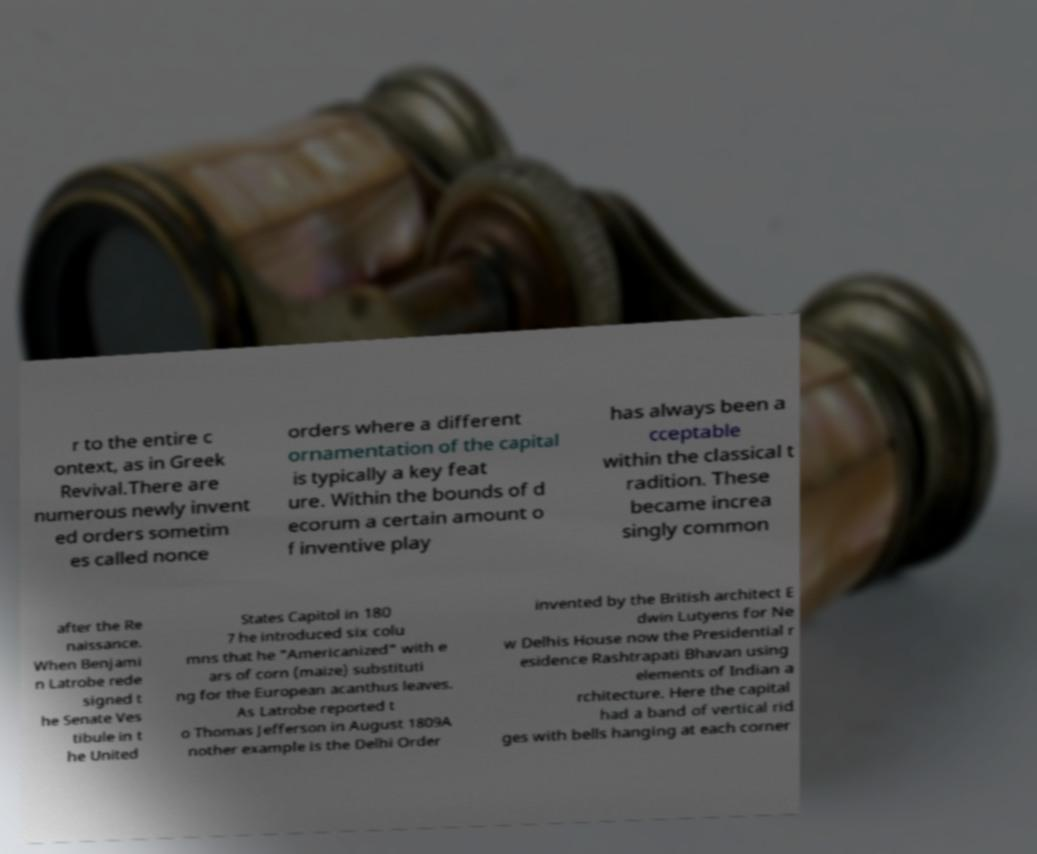Please read and relay the text visible in this image. What does it say? r to the entire c ontext, as in Greek Revival.There are numerous newly invent ed orders sometim es called nonce orders where a different ornamentation of the capital is typically a key feat ure. Within the bounds of d ecorum a certain amount o f inventive play has always been a cceptable within the classical t radition. These became increa singly common after the Re naissance. When Benjami n Latrobe rede signed t he Senate Ves tibule in t he United States Capitol in 180 7 he introduced six colu mns that he "Americanized" with e ars of corn (maize) substituti ng for the European acanthus leaves. As Latrobe reported t o Thomas Jefferson in August 1809A nother example is the Delhi Order invented by the British architect E dwin Lutyens for Ne w Delhis House now the Presidential r esidence Rashtrapati Bhavan using elements of Indian a rchitecture. Here the capital had a band of vertical rid ges with bells hanging at each corner 